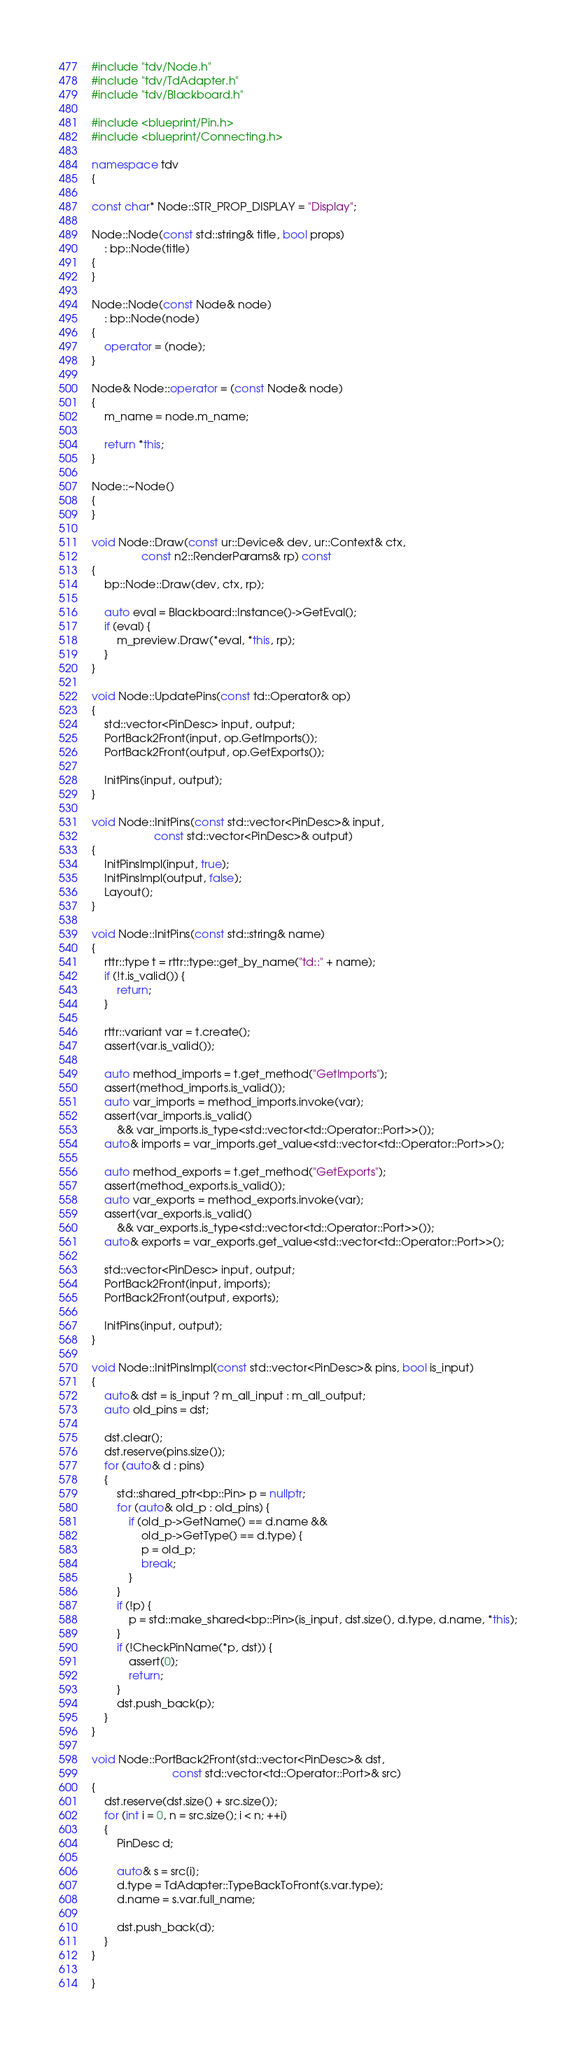Convert code to text. <code><loc_0><loc_0><loc_500><loc_500><_C++_>#include "tdv/Node.h"
#include "tdv/TdAdapter.h"
#include "tdv/Blackboard.h"

#include <blueprint/Pin.h>
#include <blueprint/Connecting.h>

namespace tdv
{

const char* Node::STR_PROP_DISPLAY = "Display";

Node::Node(const std::string& title, bool props)
    : bp::Node(title)
{
}

Node::Node(const Node& node)
    : bp::Node(node)
{
    operator = (node);
}

Node& Node::operator = (const Node& node)
{
    m_name = node.m_name;

    return *this;
}

Node::~Node()
{
}

void Node::Draw(const ur::Device& dev, ur::Context& ctx,
                const n2::RenderParams& rp) const
{
    bp::Node::Draw(dev, ctx, rp);

    auto eval = Blackboard::Instance()->GetEval();
    if (eval) {
        m_preview.Draw(*eval, *this, rp);
    }
}

void Node::UpdatePins(const td::Operator& op)
{
    std::vector<PinDesc> input, output;
    PortBack2Front(input, op.GetImports());
    PortBack2Front(output, op.GetExports());

    InitPins(input, output);
}

void Node::InitPins(const std::vector<PinDesc>& input,
                    const std::vector<PinDesc>& output)
{
    InitPinsImpl(input, true);
    InitPinsImpl(output, false);
    Layout();
}

void Node::InitPins(const std::string& name)
{
	rttr::type t = rttr::type::get_by_name("td::" + name);
    if (!t.is_valid()) {
        return;
    }

	rttr::variant var = t.create();
	assert(var.is_valid());

	auto method_imports = t.get_method("GetImports");
	assert(method_imports.is_valid());
	auto var_imports = method_imports.invoke(var);
	assert(var_imports.is_valid()
		&& var_imports.is_type<std::vector<td::Operator::Port>>());
	auto& imports = var_imports.get_value<std::vector<td::Operator::Port>>();

	auto method_exports = t.get_method("GetExports");
	assert(method_exports.is_valid());
	auto var_exports = method_exports.invoke(var);
	assert(var_exports.is_valid()
		&& var_exports.is_type<std::vector<td::Operator::Port>>());
	auto& exports = var_exports.get_value<std::vector<td::Operator::Port>>();

	std::vector<PinDesc> input, output;
    PortBack2Front(input, imports);
    PortBack2Front(output, exports);

	InitPins(input, output);
}

void Node::InitPinsImpl(const std::vector<PinDesc>& pins, bool is_input)
{
    auto& dst = is_input ? m_all_input : m_all_output;
    auto old_pins = dst;

	dst.clear();
	dst.reserve(pins.size());
	for (auto& d : pins)
	{
        std::shared_ptr<bp::Pin> p = nullptr;
        for (auto& old_p : old_pins) {
            if (old_p->GetName() == d.name &&
                old_p->GetType() == d.type) {
                p = old_p;
                break;
            }
        }
        if (!p) {
            p = std::make_shared<bp::Pin>(is_input, dst.size(), d.type, d.name, *this);
        }
		if (!CheckPinName(*p, dst)) {
			assert(0);
			return;
		}
		dst.push_back(p);
	}
}

void Node::PortBack2Front(std::vector<PinDesc>& dst,
                          const std::vector<td::Operator::Port>& src)
{
	dst.reserve(dst.size() + src.size());
	for (int i = 0, n = src.size(); i < n; ++i)
	{
        PinDesc d;

		auto& s = src[i];
        d.type = TdAdapter::TypeBackToFront(s.var.type);
        d.name = s.var.full_name;

        dst.push_back(d);
	}
}

}</code> 